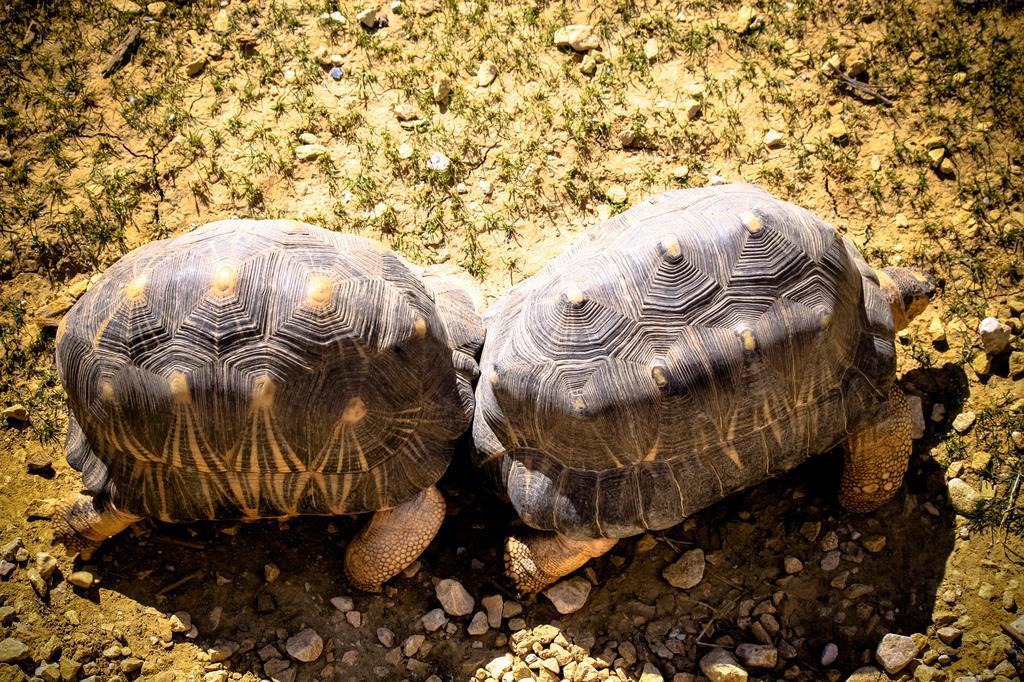Could you give a brief overview of what you see in this image? In this image there are two tortoises on the path. 